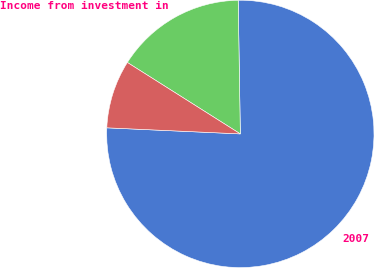<chart> <loc_0><loc_0><loc_500><loc_500><pie_chart><fcel>2007<fcel>Income from investment in<fcel>Unnamed: 2<nl><fcel>75.98%<fcel>15.77%<fcel>8.25%<nl></chart> 